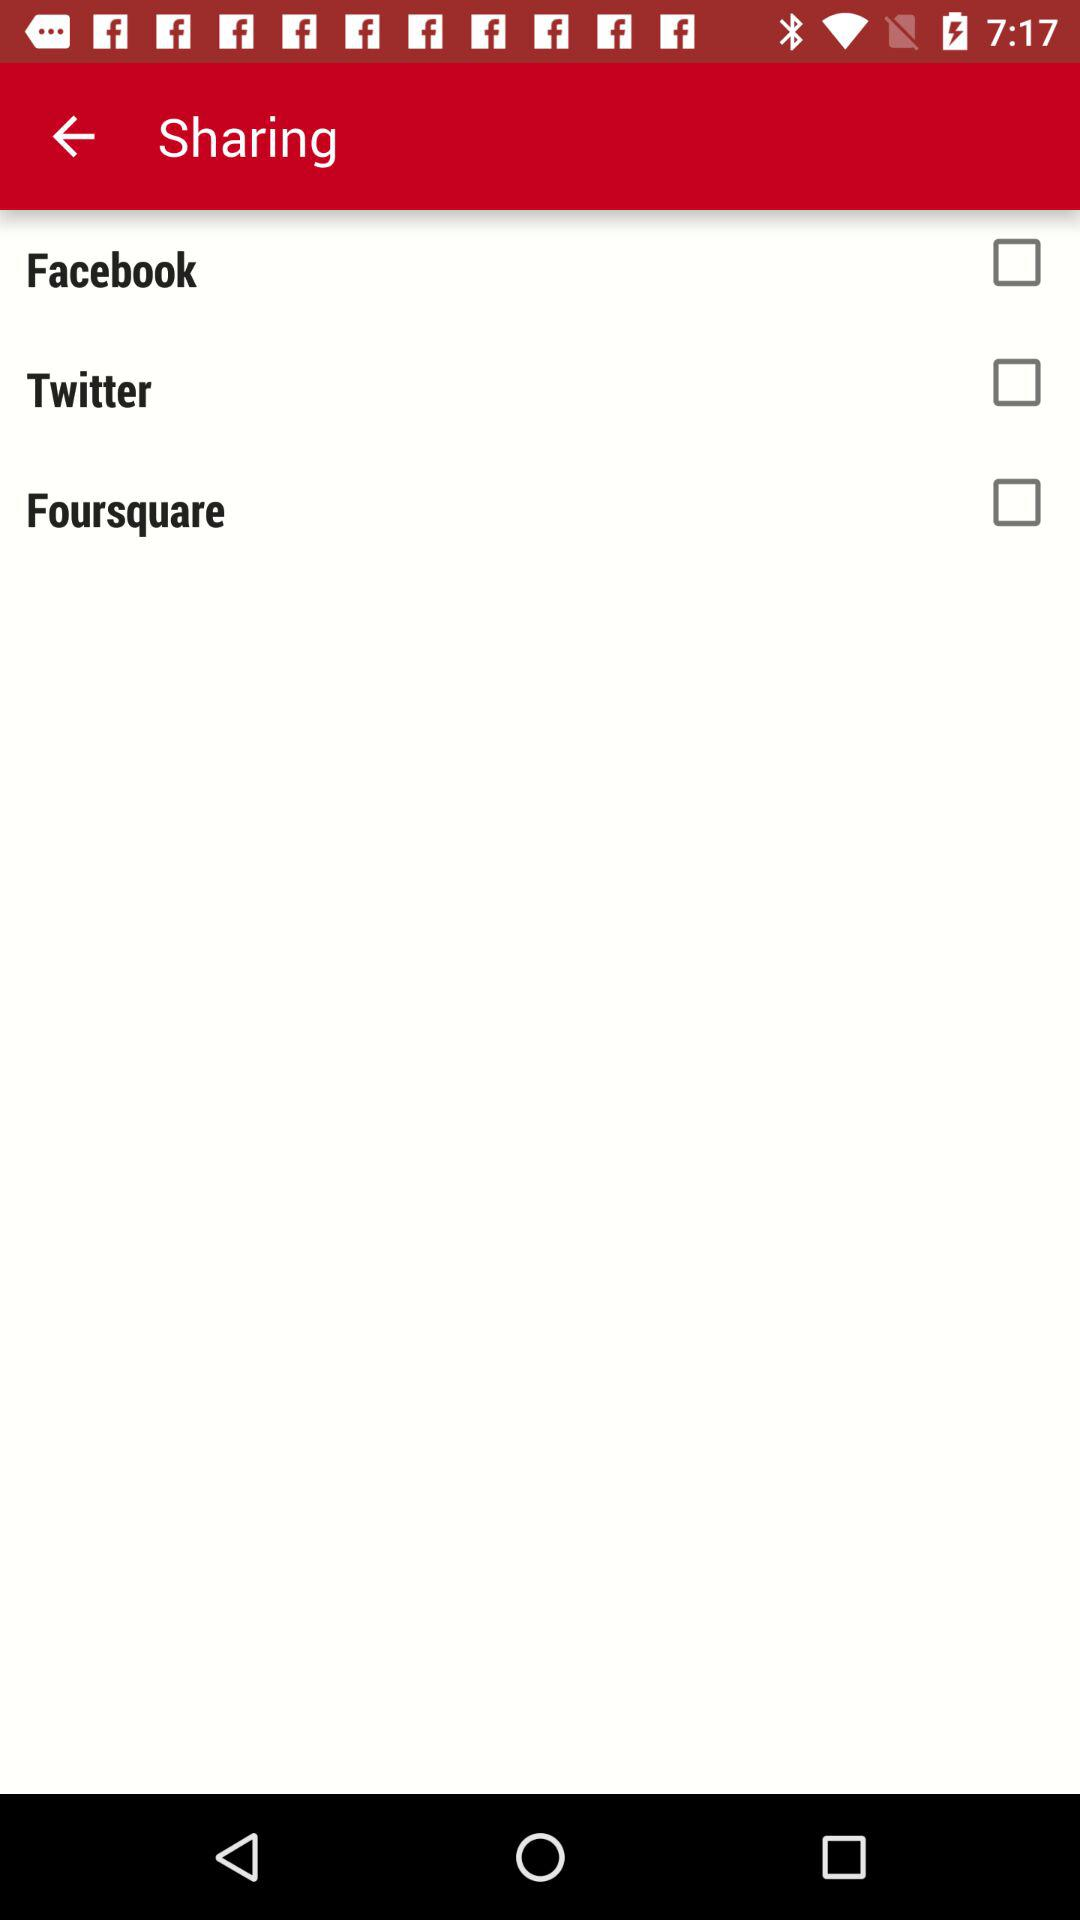What is the status of "Facebook"? The status is "off". 